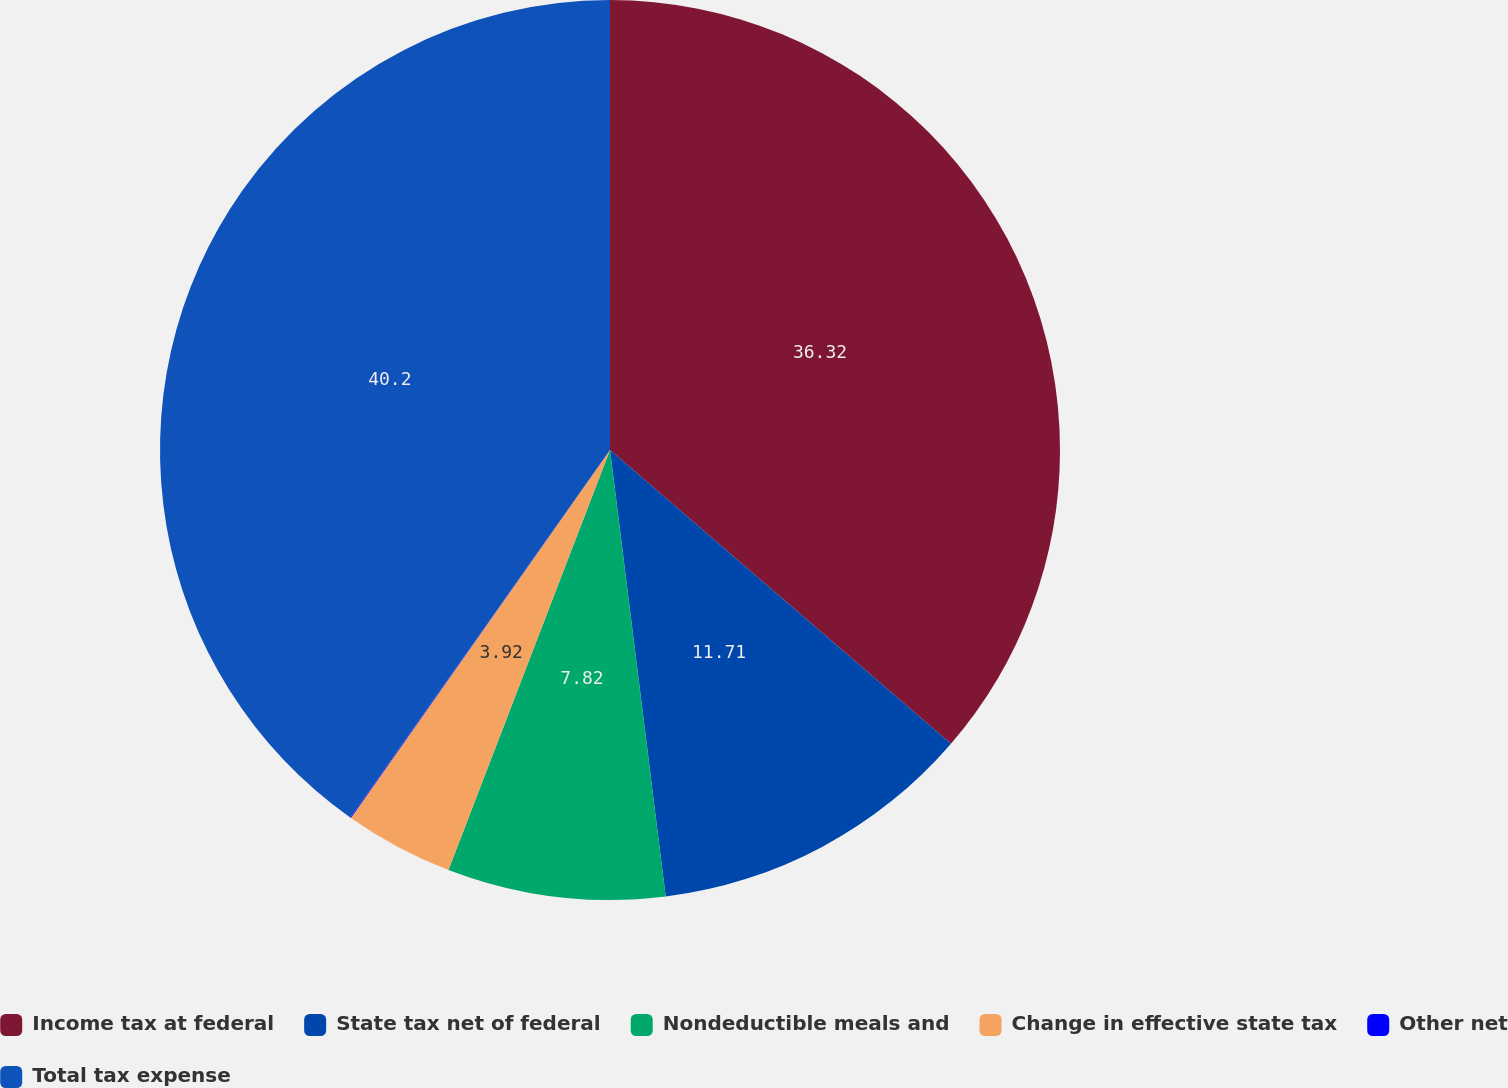Convert chart to OTSL. <chart><loc_0><loc_0><loc_500><loc_500><pie_chart><fcel>Income tax at federal<fcel>State tax net of federal<fcel>Nondeductible meals and<fcel>Change in effective state tax<fcel>Other net<fcel>Total tax expense<nl><fcel>36.32%<fcel>11.71%<fcel>7.82%<fcel>3.92%<fcel>0.03%<fcel>40.21%<nl></chart> 